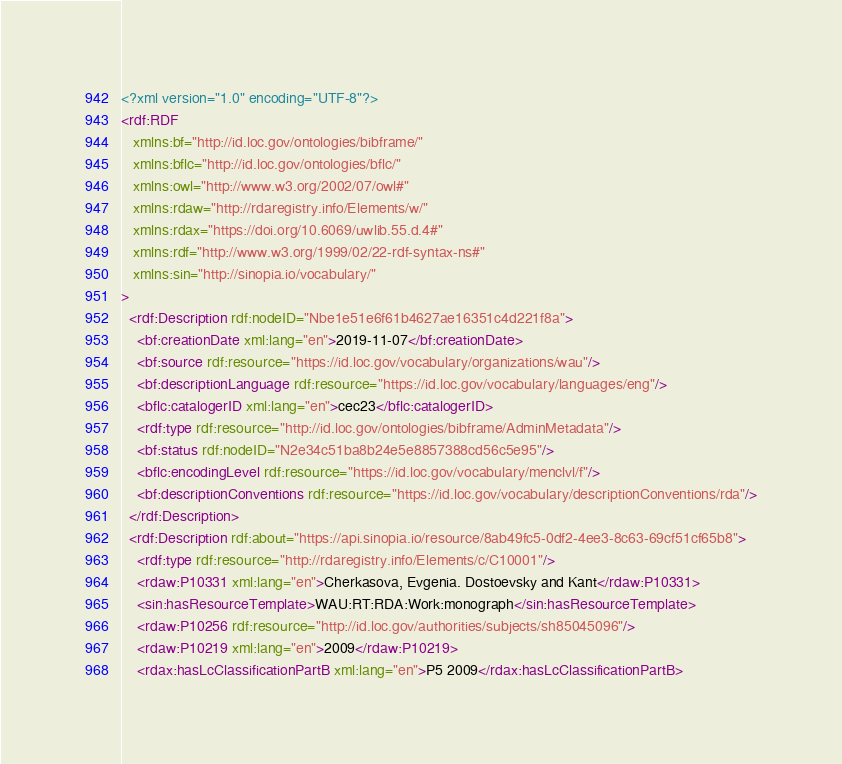<code> <loc_0><loc_0><loc_500><loc_500><_XML_><?xml version="1.0" encoding="UTF-8"?>
<rdf:RDF
   xmlns:bf="http://id.loc.gov/ontologies/bibframe/"
   xmlns:bflc="http://id.loc.gov/ontologies/bflc/"
   xmlns:owl="http://www.w3.org/2002/07/owl#"
   xmlns:rdaw="http://rdaregistry.info/Elements/w/"
   xmlns:rdax="https://doi.org/10.6069/uwlib.55.d.4#"
   xmlns:rdf="http://www.w3.org/1999/02/22-rdf-syntax-ns#"
   xmlns:sin="http://sinopia.io/vocabulary/"
>
  <rdf:Description rdf:nodeID="Nbe1e51e6f61b4627ae16351c4d221f8a">
    <bf:creationDate xml:lang="en">2019-11-07</bf:creationDate>
    <bf:source rdf:resource="https://id.loc.gov/vocabulary/organizations/wau"/>
    <bf:descriptionLanguage rdf:resource="https://id.loc.gov/vocabulary/languages/eng"/>
    <bflc:catalogerID xml:lang="en">cec23</bflc:catalogerID>
    <rdf:type rdf:resource="http://id.loc.gov/ontologies/bibframe/AdminMetadata"/>
    <bf:status rdf:nodeID="N2e34c51ba8b24e5e8857388cd56c5e95"/>
    <bflc:encodingLevel rdf:resource="https://id.loc.gov/vocabulary/menclvl/f"/>
    <bf:descriptionConventions rdf:resource="https://id.loc.gov/vocabulary/descriptionConventions/rda"/>
  </rdf:Description>
  <rdf:Description rdf:about="https://api.sinopia.io/resource/8ab49fc5-0df2-4ee3-8c63-69cf51cf65b8">
    <rdf:type rdf:resource="http://rdaregistry.info/Elements/c/C10001"/>
    <rdaw:P10331 xml:lang="en">Cherkasova, Evgenia. Dostoevsky and Kant</rdaw:P10331>
    <sin:hasResourceTemplate>WAU:RT:RDA:Work:monograph</sin:hasResourceTemplate>
    <rdaw:P10256 rdf:resource="http://id.loc.gov/authorities/subjects/sh85045096"/>
    <rdaw:P10219 xml:lang="en">2009</rdaw:P10219>
    <rdax:hasLcClassificationPartB xml:lang="en">P5 2009</rdax:hasLcClassificationPartB></code> 